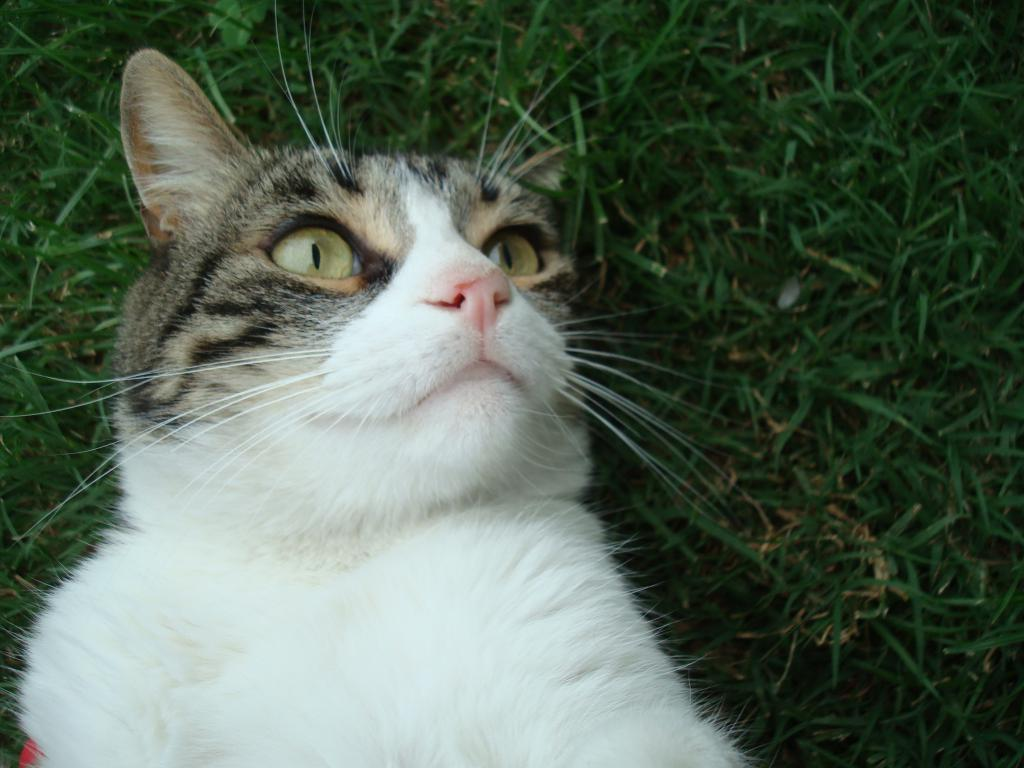What type of animal is in the image? There is a cat in the image. Where is the cat located? The cat is on the grass. What type of wood is the cat using to build a van in the image? There is no wood or van present in the image; it features a cat on the grass. 